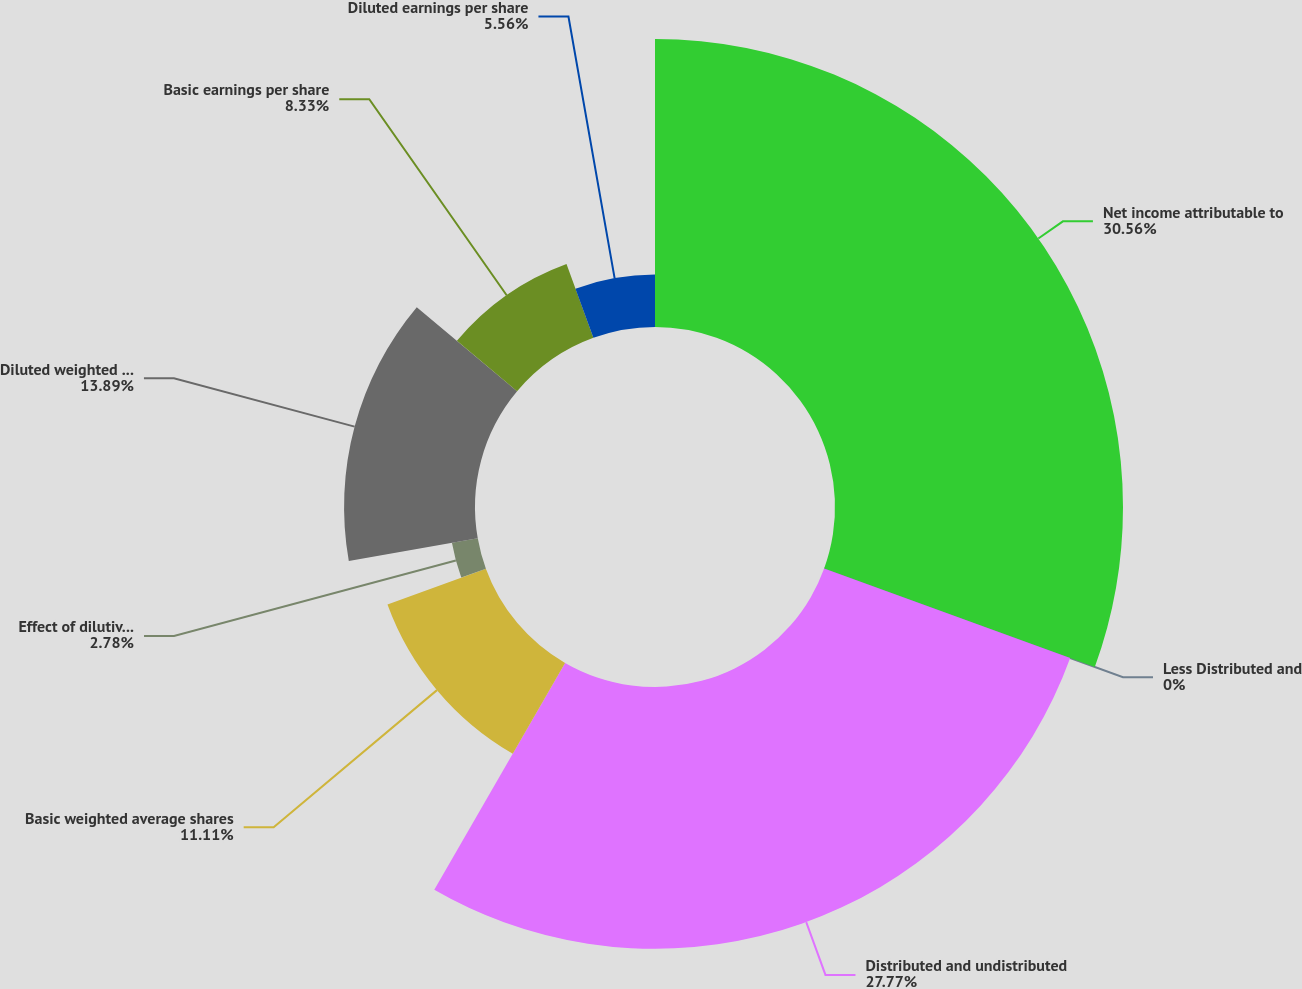Convert chart to OTSL. <chart><loc_0><loc_0><loc_500><loc_500><pie_chart><fcel>Net income attributable to<fcel>Less Distributed and<fcel>Distributed and undistributed<fcel>Basic weighted average shares<fcel>Effect of dilutive stock<fcel>Diluted weighted average<fcel>Basic earnings per share<fcel>Diluted earnings per share<nl><fcel>30.55%<fcel>0.0%<fcel>27.77%<fcel>11.11%<fcel>2.78%<fcel>13.89%<fcel>8.33%<fcel>5.56%<nl></chart> 